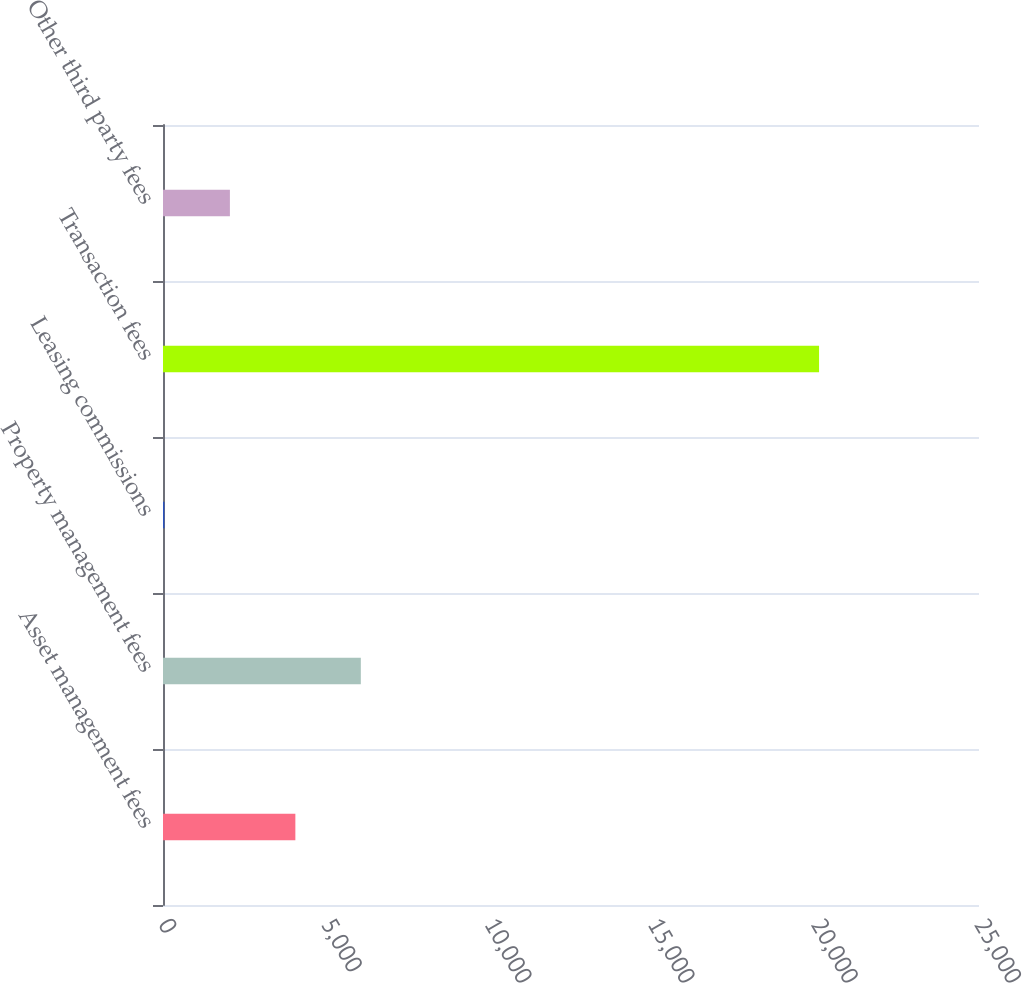Convert chart. <chart><loc_0><loc_0><loc_500><loc_500><bar_chart><fcel>Asset management fees<fcel>Property management fees<fcel>Leasing commissions<fcel>Transaction fees<fcel>Other third party fees<nl><fcel>4055.2<fcel>6060.8<fcel>44<fcel>20100<fcel>2049.6<nl></chart> 